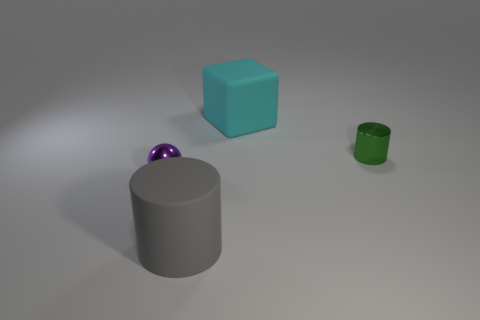Add 3 big purple rubber spheres. How many objects exist? 7 Subtract all spheres. How many objects are left? 3 Subtract all big cylinders. Subtract all big gray cylinders. How many objects are left? 2 Add 4 metal spheres. How many metal spheres are left? 5 Add 3 small metallic spheres. How many small metallic spheres exist? 4 Subtract 0 gray balls. How many objects are left? 4 